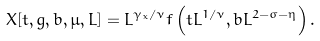<formula> <loc_0><loc_0><loc_500><loc_500>X [ t , g , b , \mu , L ] = L ^ { \gamma _ { x } / \nu } f \left ( t L ^ { 1 / \nu } , b L ^ { 2 - \sigma - \eta } \right ) .</formula> 